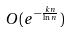Convert formula to latex. <formula><loc_0><loc_0><loc_500><loc_500>O ( e ^ { - \frac { k n } { \ln n } } )</formula> 